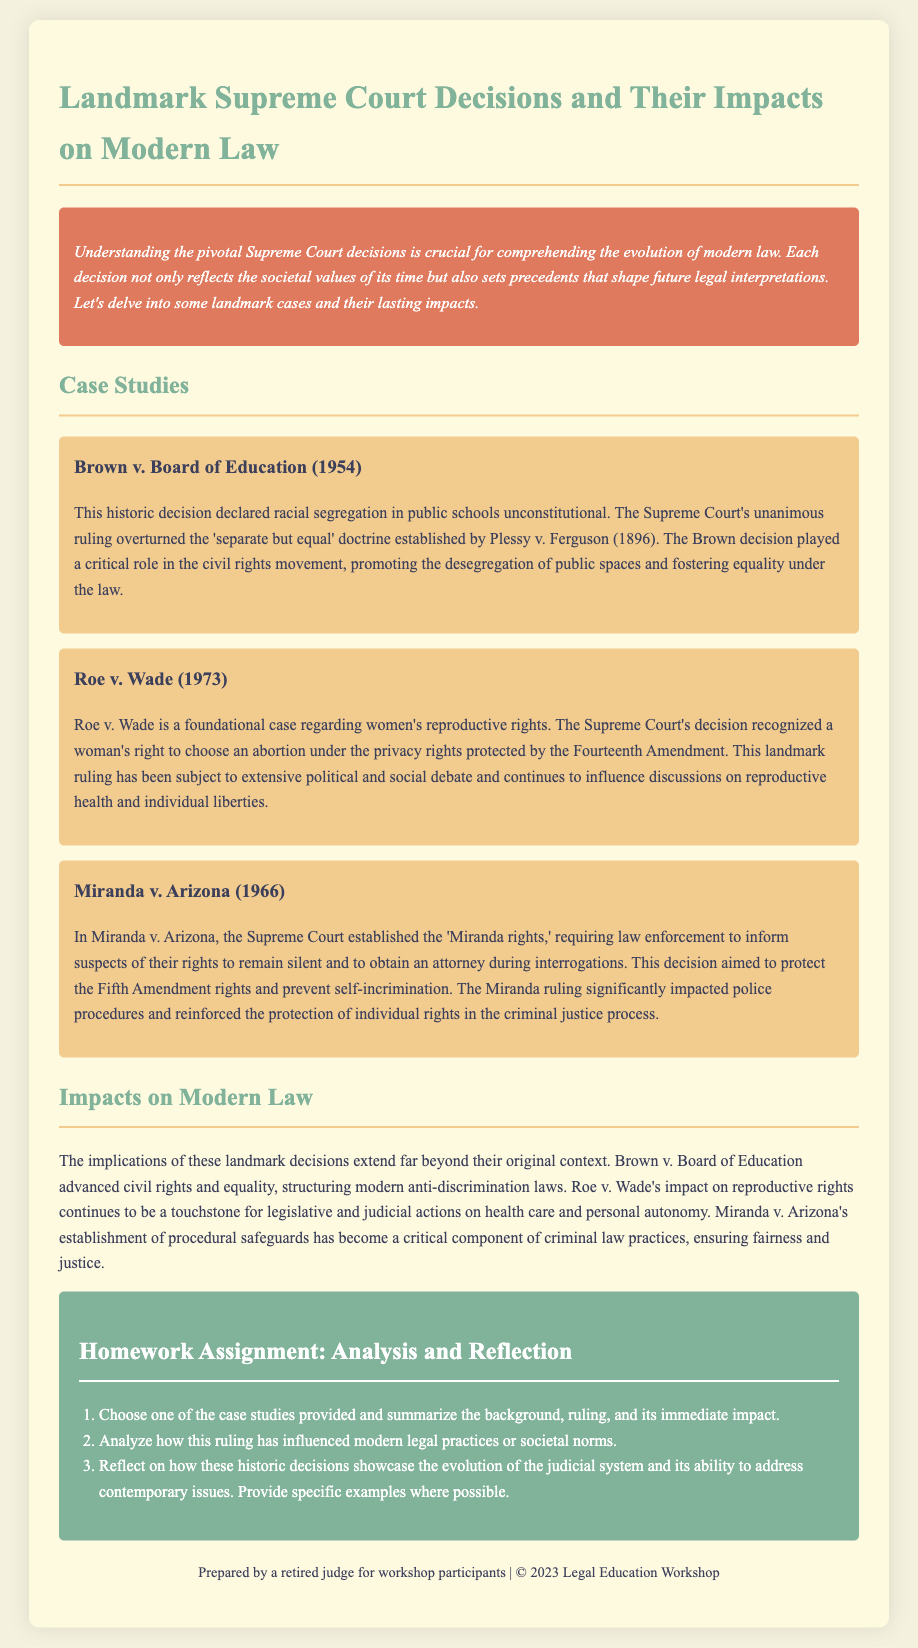What landmark case declared racial segregation in public schools unconstitutional? The document states that Brown v. Board of Education (1954) declared racial segregation in public schools unconstitutional.
Answer: Brown v. Board of Education What year was Roe v. Wade decided? The document specifies that Roe v. Wade was decided in 1973.
Answer: 1973 What rights does Miranda v. Arizona protect? The document mentions that Miranda v. Arizona protects the Fifth Amendment rights, requiring law enforcement to inform suspects of their rights.
Answer: Fifth Amendment rights Which case established the 'Miranda rights'? The document indicates that Miranda v. Arizona established the 'Miranda rights.'
Answer: Miranda v. Arizona What was the immediate impact of Brown v. Board of Education? The document states that Brown v. Board of Education played a critical role in the civil rights movement, promoting desegregation.
Answer: Promoting desegregation How has Roe v. Wade influenced modern legal practices? The document notes that Roe v. Wade continues to influence discussions on reproductive health and individual liberties in modern legal practices.
Answer: Discussions on reproductive health In which document section might you find an overview of Brown v. Board of Education? The document reflects that the case studies section contains an overview of Brown v. Board of Education.
Answer: Case Studies What does the homework assignment focus on analyzing? The homework assignment focuses on analyzing selected case studies and their impacts.
Answer: Selected case studies and their impacts How many case studies are provided in the document? The document provides three case studies on landmark decisions.
Answer: Three case studies 